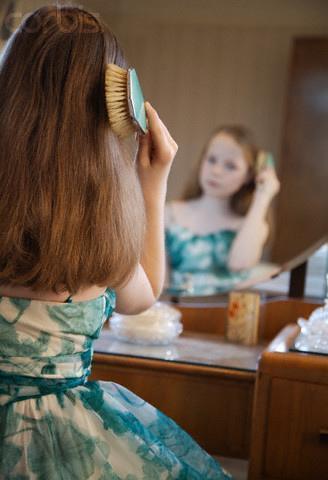How many people are there?
Give a very brief answer. 2. 